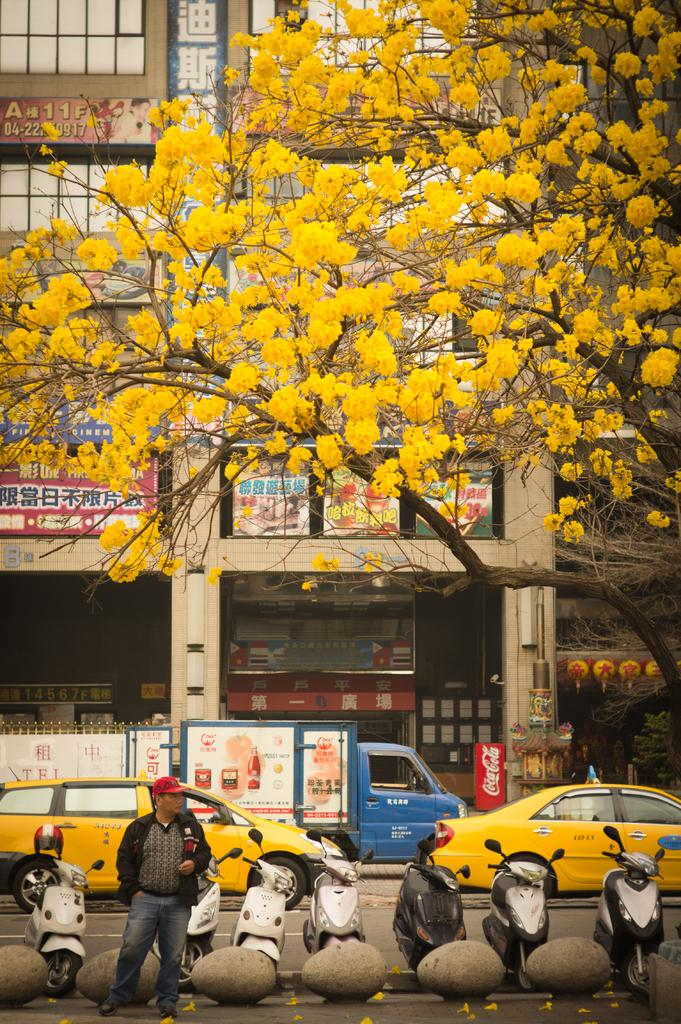<image>
Create a compact narrative representing the image presented. A man is standing under a tree with yellow flowers and a Coca-Cola machine is in the background. 